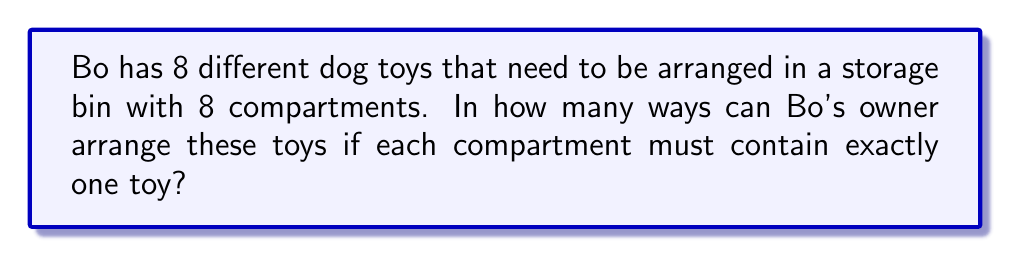Can you solve this math problem? Let's approach this step-by-step:

1) This is a permutation problem because:
   - We are arranging all 8 toys
   - The order matters (different arrangements are considered distinct)
   - Each toy is used exactly once

2) The formula for permutations of n distinct objects is:

   $$P(n) = n!$$

3) In this case, n = 8 (the number of toys)

4) Therefore, the number of ways to arrange the toys is:

   $$P(8) = 8!$$

5) Let's calculate 8!:
   
   $$8! = 8 \times 7 \times 6 \times 5 \times 4 \times 3 \times 2 \times 1 = 40,320$$

Thus, there are 40,320 ways to arrange Bo's 8 toys in the storage bin.
Answer: 40,320 